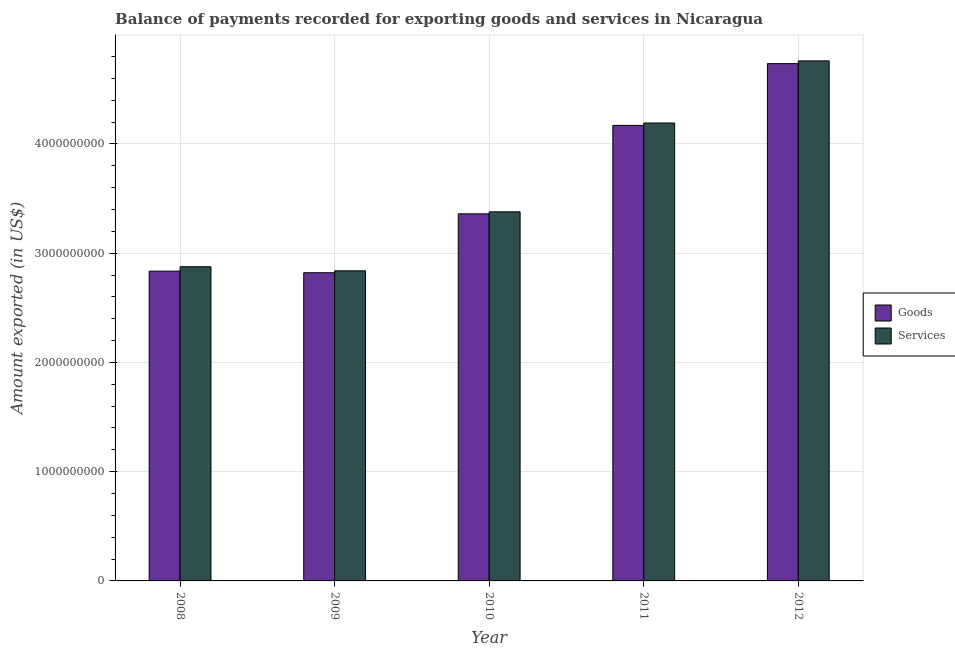How many different coloured bars are there?
Make the answer very short. 2. Are the number of bars per tick equal to the number of legend labels?
Your answer should be compact. Yes. Are the number of bars on each tick of the X-axis equal?
Ensure brevity in your answer.  Yes. How many bars are there on the 2nd tick from the right?
Keep it short and to the point. 2. In how many cases, is the number of bars for a given year not equal to the number of legend labels?
Offer a very short reply. 0. What is the amount of goods exported in 2012?
Provide a succinct answer. 4.74e+09. Across all years, what is the maximum amount of services exported?
Provide a succinct answer. 4.76e+09. Across all years, what is the minimum amount of services exported?
Make the answer very short. 2.84e+09. In which year was the amount of goods exported minimum?
Offer a terse response. 2009. What is the total amount of services exported in the graph?
Your answer should be compact. 1.80e+1. What is the difference between the amount of goods exported in 2008 and that in 2012?
Give a very brief answer. -1.90e+09. What is the difference between the amount of goods exported in 2012 and the amount of services exported in 2009?
Give a very brief answer. 1.91e+09. What is the average amount of goods exported per year?
Ensure brevity in your answer.  3.58e+09. In the year 2008, what is the difference between the amount of goods exported and amount of services exported?
Your response must be concise. 0. In how many years, is the amount of services exported greater than 2800000000 US$?
Offer a very short reply. 5. What is the ratio of the amount of services exported in 2008 to that in 2011?
Provide a short and direct response. 0.69. Is the difference between the amount of services exported in 2010 and 2011 greater than the difference between the amount of goods exported in 2010 and 2011?
Offer a terse response. No. What is the difference between the highest and the second highest amount of goods exported?
Your answer should be very brief. 5.65e+08. What is the difference between the highest and the lowest amount of services exported?
Offer a terse response. 1.92e+09. In how many years, is the amount of goods exported greater than the average amount of goods exported taken over all years?
Offer a terse response. 2. What does the 1st bar from the left in 2008 represents?
Your answer should be compact. Goods. What does the 2nd bar from the right in 2012 represents?
Offer a very short reply. Goods. How many years are there in the graph?
Your response must be concise. 5. Are the values on the major ticks of Y-axis written in scientific E-notation?
Your answer should be very brief. No. How many legend labels are there?
Provide a succinct answer. 2. What is the title of the graph?
Give a very brief answer. Balance of payments recorded for exporting goods and services in Nicaragua. Does "Formally registered" appear as one of the legend labels in the graph?
Make the answer very short. No. What is the label or title of the Y-axis?
Make the answer very short. Amount exported (in US$). What is the Amount exported (in US$) in Goods in 2008?
Your answer should be very brief. 2.84e+09. What is the Amount exported (in US$) of Services in 2008?
Give a very brief answer. 2.88e+09. What is the Amount exported (in US$) of Goods in 2009?
Your answer should be very brief. 2.82e+09. What is the Amount exported (in US$) of Services in 2009?
Offer a terse response. 2.84e+09. What is the Amount exported (in US$) in Goods in 2010?
Offer a terse response. 3.36e+09. What is the Amount exported (in US$) of Services in 2010?
Keep it short and to the point. 3.38e+09. What is the Amount exported (in US$) of Goods in 2011?
Provide a short and direct response. 4.17e+09. What is the Amount exported (in US$) of Services in 2011?
Make the answer very short. 4.19e+09. What is the Amount exported (in US$) of Goods in 2012?
Offer a terse response. 4.74e+09. What is the Amount exported (in US$) in Services in 2012?
Offer a very short reply. 4.76e+09. Across all years, what is the maximum Amount exported (in US$) of Goods?
Your answer should be very brief. 4.74e+09. Across all years, what is the maximum Amount exported (in US$) in Services?
Keep it short and to the point. 4.76e+09. Across all years, what is the minimum Amount exported (in US$) in Goods?
Your response must be concise. 2.82e+09. Across all years, what is the minimum Amount exported (in US$) in Services?
Make the answer very short. 2.84e+09. What is the total Amount exported (in US$) in Goods in the graph?
Provide a short and direct response. 1.79e+1. What is the total Amount exported (in US$) of Services in the graph?
Ensure brevity in your answer.  1.80e+1. What is the difference between the Amount exported (in US$) of Goods in 2008 and that in 2009?
Give a very brief answer. 1.44e+07. What is the difference between the Amount exported (in US$) in Services in 2008 and that in 2009?
Your answer should be very brief. 3.75e+07. What is the difference between the Amount exported (in US$) in Goods in 2008 and that in 2010?
Offer a terse response. -5.25e+08. What is the difference between the Amount exported (in US$) in Services in 2008 and that in 2010?
Your response must be concise. -5.02e+08. What is the difference between the Amount exported (in US$) of Goods in 2008 and that in 2011?
Your answer should be compact. -1.33e+09. What is the difference between the Amount exported (in US$) in Services in 2008 and that in 2011?
Offer a terse response. -1.32e+09. What is the difference between the Amount exported (in US$) of Goods in 2008 and that in 2012?
Your response must be concise. -1.90e+09. What is the difference between the Amount exported (in US$) of Services in 2008 and that in 2012?
Give a very brief answer. -1.88e+09. What is the difference between the Amount exported (in US$) in Goods in 2009 and that in 2010?
Make the answer very short. -5.39e+08. What is the difference between the Amount exported (in US$) in Services in 2009 and that in 2010?
Make the answer very short. -5.40e+08. What is the difference between the Amount exported (in US$) in Goods in 2009 and that in 2011?
Provide a succinct answer. -1.35e+09. What is the difference between the Amount exported (in US$) of Services in 2009 and that in 2011?
Provide a succinct answer. -1.35e+09. What is the difference between the Amount exported (in US$) of Goods in 2009 and that in 2012?
Offer a very short reply. -1.91e+09. What is the difference between the Amount exported (in US$) of Services in 2009 and that in 2012?
Offer a very short reply. -1.92e+09. What is the difference between the Amount exported (in US$) in Goods in 2010 and that in 2011?
Your response must be concise. -8.10e+08. What is the difference between the Amount exported (in US$) in Services in 2010 and that in 2011?
Your response must be concise. -8.13e+08. What is the difference between the Amount exported (in US$) in Goods in 2010 and that in 2012?
Provide a short and direct response. -1.37e+09. What is the difference between the Amount exported (in US$) of Services in 2010 and that in 2012?
Make the answer very short. -1.38e+09. What is the difference between the Amount exported (in US$) of Goods in 2011 and that in 2012?
Offer a very short reply. -5.65e+08. What is the difference between the Amount exported (in US$) of Services in 2011 and that in 2012?
Your answer should be very brief. -5.69e+08. What is the difference between the Amount exported (in US$) of Goods in 2008 and the Amount exported (in US$) of Services in 2009?
Your answer should be compact. -2.90e+06. What is the difference between the Amount exported (in US$) of Goods in 2008 and the Amount exported (in US$) of Services in 2010?
Ensure brevity in your answer.  -5.43e+08. What is the difference between the Amount exported (in US$) in Goods in 2008 and the Amount exported (in US$) in Services in 2011?
Give a very brief answer. -1.36e+09. What is the difference between the Amount exported (in US$) in Goods in 2008 and the Amount exported (in US$) in Services in 2012?
Offer a terse response. -1.92e+09. What is the difference between the Amount exported (in US$) in Goods in 2009 and the Amount exported (in US$) in Services in 2010?
Provide a short and direct response. -5.57e+08. What is the difference between the Amount exported (in US$) in Goods in 2009 and the Amount exported (in US$) in Services in 2011?
Ensure brevity in your answer.  -1.37e+09. What is the difference between the Amount exported (in US$) of Goods in 2009 and the Amount exported (in US$) of Services in 2012?
Make the answer very short. -1.94e+09. What is the difference between the Amount exported (in US$) in Goods in 2010 and the Amount exported (in US$) in Services in 2011?
Your response must be concise. -8.31e+08. What is the difference between the Amount exported (in US$) of Goods in 2010 and the Amount exported (in US$) of Services in 2012?
Offer a terse response. -1.40e+09. What is the difference between the Amount exported (in US$) of Goods in 2011 and the Amount exported (in US$) of Services in 2012?
Your response must be concise. -5.90e+08. What is the average Amount exported (in US$) in Goods per year?
Provide a short and direct response. 3.58e+09. What is the average Amount exported (in US$) in Services per year?
Provide a succinct answer. 3.61e+09. In the year 2008, what is the difference between the Amount exported (in US$) of Goods and Amount exported (in US$) of Services?
Offer a terse response. -4.04e+07. In the year 2009, what is the difference between the Amount exported (in US$) of Goods and Amount exported (in US$) of Services?
Your answer should be very brief. -1.73e+07. In the year 2010, what is the difference between the Amount exported (in US$) in Goods and Amount exported (in US$) in Services?
Your answer should be very brief. -1.82e+07. In the year 2011, what is the difference between the Amount exported (in US$) of Goods and Amount exported (in US$) of Services?
Ensure brevity in your answer.  -2.16e+07. In the year 2012, what is the difference between the Amount exported (in US$) in Goods and Amount exported (in US$) in Services?
Ensure brevity in your answer.  -2.52e+07. What is the ratio of the Amount exported (in US$) of Services in 2008 to that in 2009?
Ensure brevity in your answer.  1.01. What is the ratio of the Amount exported (in US$) of Goods in 2008 to that in 2010?
Make the answer very short. 0.84. What is the ratio of the Amount exported (in US$) of Services in 2008 to that in 2010?
Your response must be concise. 0.85. What is the ratio of the Amount exported (in US$) in Goods in 2008 to that in 2011?
Provide a short and direct response. 0.68. What is the ratio of the Amount exported (in US$) of Services in 2008 to that in 2011?
Your answer should be compact. 0.69. What is the ratio of the Amount exported (in US$) of Goods in 2008 to that in 2012?
Give a very brief answer. 0.6. What is the ratio of the Amount exported (in US$) of Services in 2008 to that in 2012?
Your answer should be compact. 0.6. What is the ratio of the Amount exported (in US$) of Goods in 2009 to that in 2010?
Offer a terse response. 0.84. What is the ratio of the Amount exported (in US$) in Services in 2009 to that in 2010?
Make the answer very short. 0.84. What is the ratio of the Amount exported (in US$) of Goods in 2009 to that in 2011?
Offer a very short reply. 0.68. What is the ratio of the Amount exported (in US$) in Services in 2009 to that in 2011?
Your answer should be compact. 0.68. What is the ratio of the Amount exported (in US$) of Goods in 2009 to that in 2012?
Your answer should be compact. 0.6. What is the ratio of the Amount exported (in US$) of Services in 2009 to that in 2012?
Keep it short and to the point. 0.6. What is the ratio of the Amount exported (in US$) of Goods in 2010 to that in 2011?
Offer a very short reply. 0.81. What is the ratio of the Amount exported (in US$) of Services in 2010 to that in 2011?
Your answer should be very brief. 0.81. What is the ratio of the Amount exported (in US$) of Goods in 2010 to that in 2012?
Give a very brief answer. 0.71. What is the ratio of the Amount exported (in US$) in Services in 2010 to that in 2012?
Offer a terse response. 0.71. What is the ratio of the Amount exported (in US$) in Goods in 2011 to that in 2012?
Provide a short and direct response. 0.88. What is the ratio of the Amount exported (in US$) in Services in 2011 to that in 2012?
Give a very brief answer. 0.88. What is the difference between the highest and the second highest Amount exported (in US$) in Goods?
Provide a short and direct response. 5.65e+08. What is the difference between the highest and the second highest Amount exported (in US$) in Services?
Provide a succinct answer. 5.69e+08. What is the difference between the highest and the lowest Amount exported (in US$) of Goods?
Provide a short and direct response. 1.91e+09. What is the difference between the highest and the lowest Amount exported (in US$) of Services?
Give a very brief answer. 1.92e+09. 